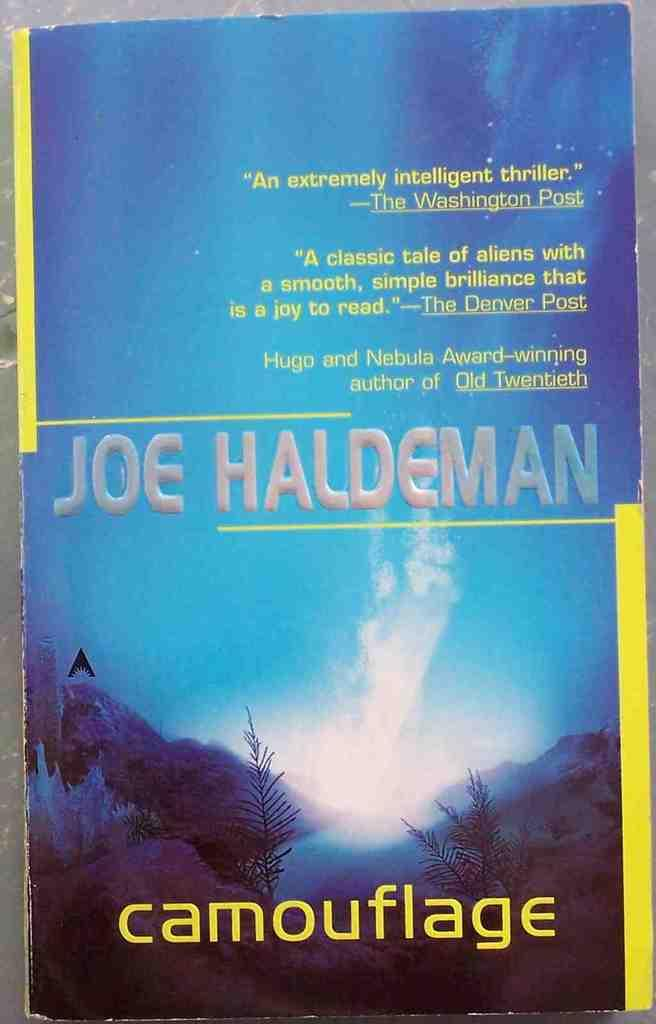<image>
Write a terse but informative summary of the picture. a book with the word camouflage at the bottom 